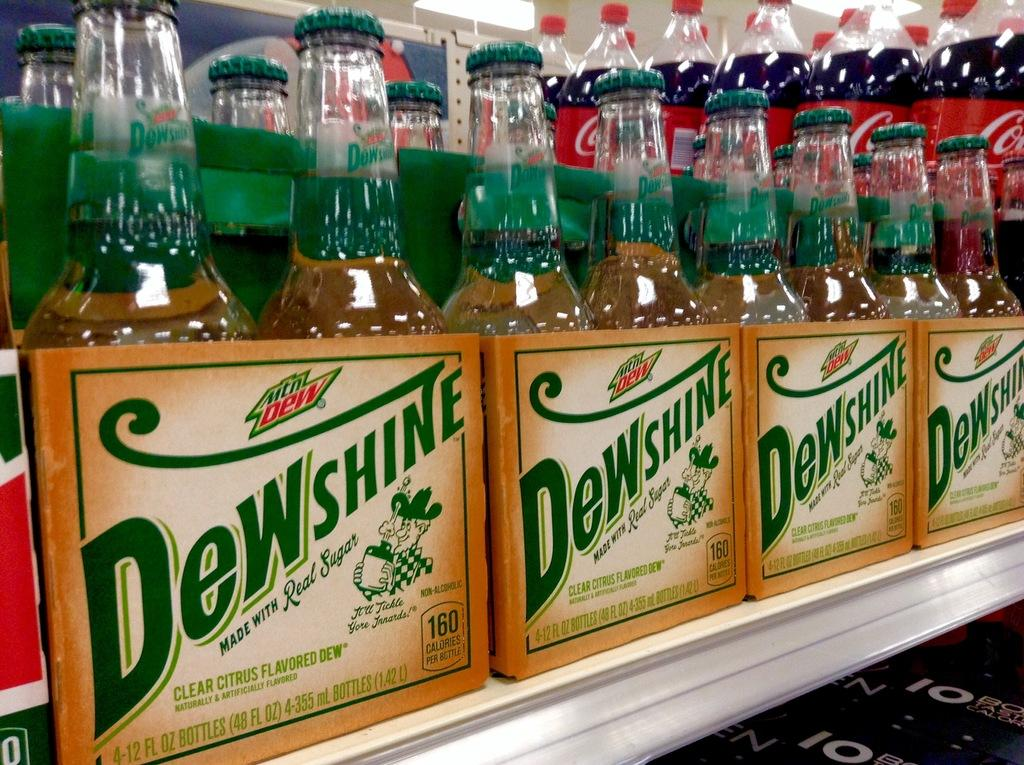Provide a one-sentence caption for the provided image. Four-packs of Dewshine bottles in rows on a shelf. 